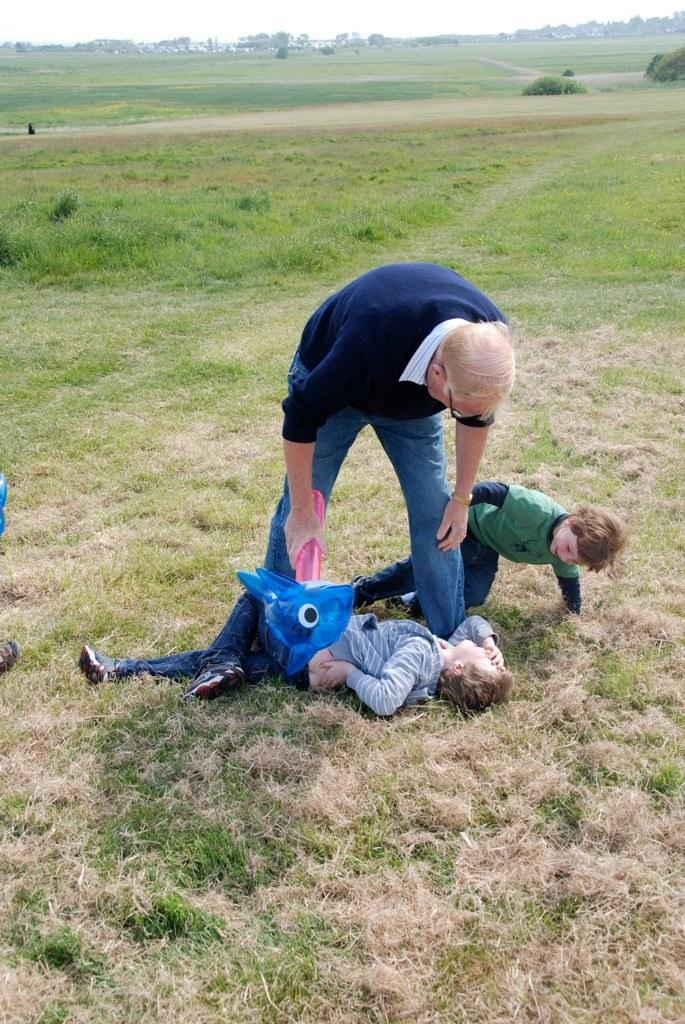Who is the main subject in the center of the image? There is a man and two children in the center of the image. What is the surrounding environment like in the image? There is grassland surrounding the area in the image. What type of veil is draped over the mailbox in the image? There is no mailbox or veil present in the image. What is the texture of the grass in the image? The texture of the grass cannot be determined from the image alone, as it is a two-dimensional representation. 